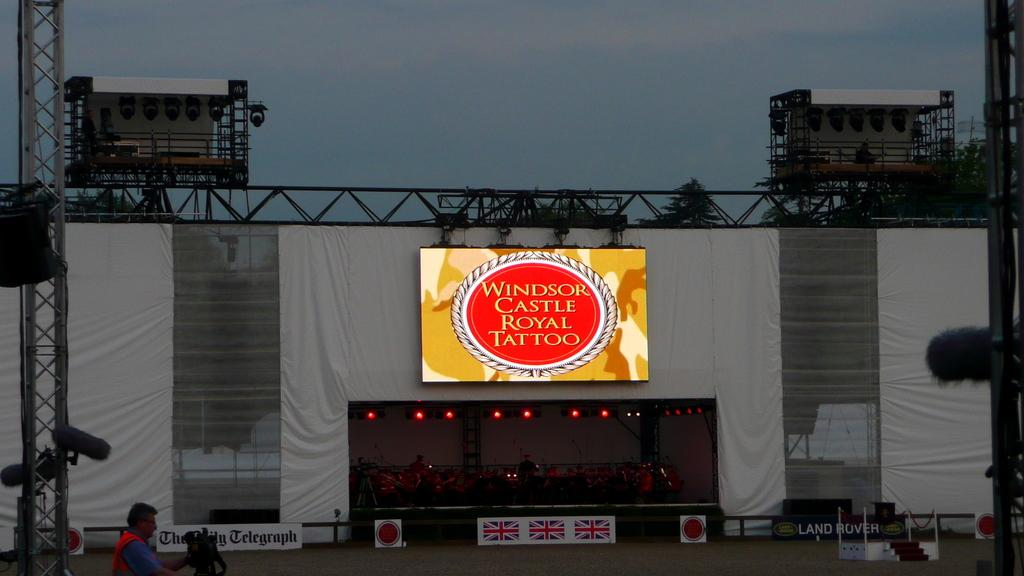<image>
Offer a succinct explanation of the picture presented. Welcome to the Windsor Castle Royal Tattoo, advertising Land Rover. 